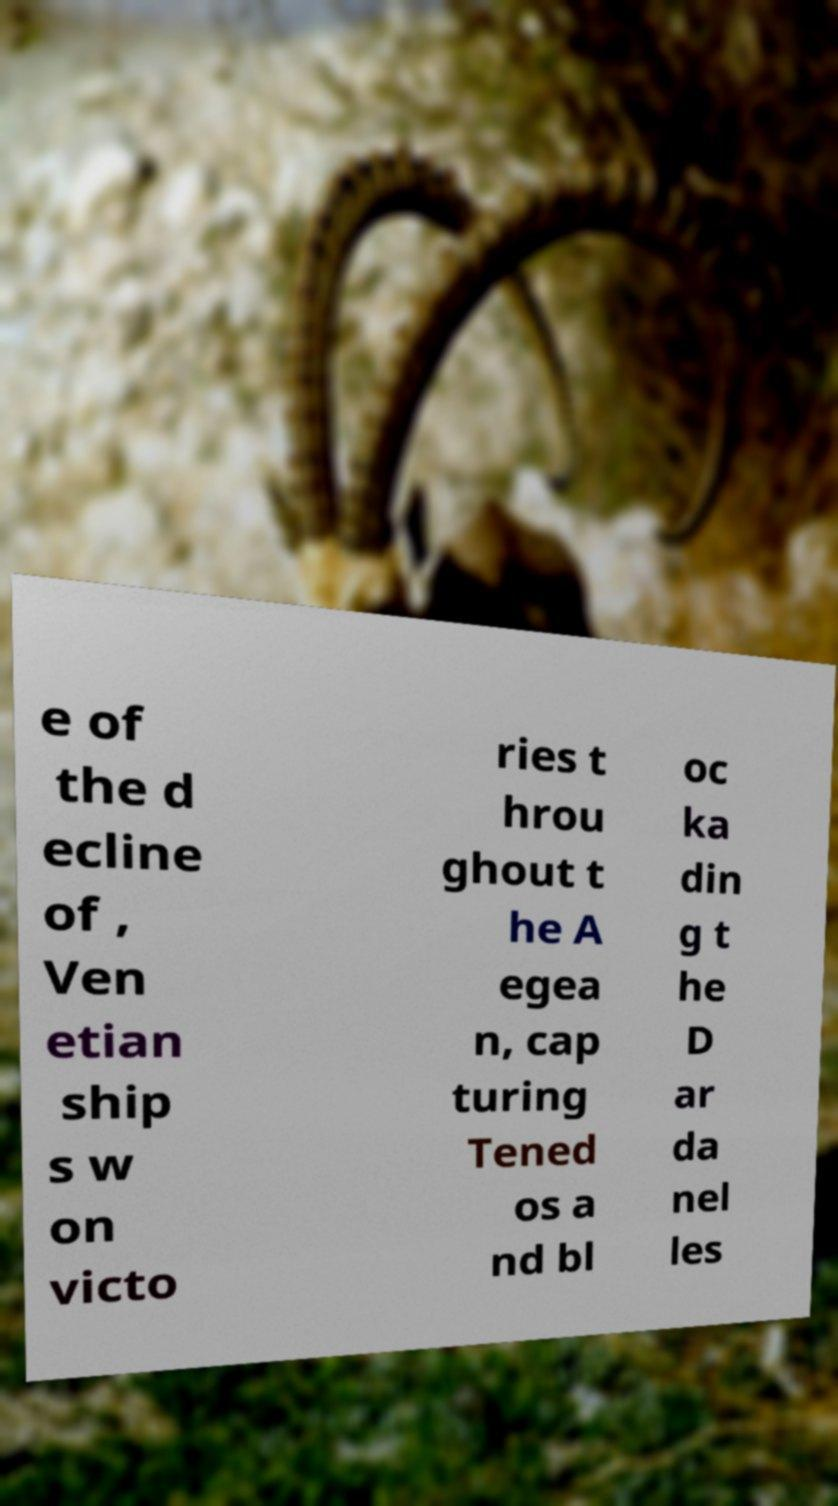Please read and relay the text visible in this image. What does it say? e of the d ecline of , Ven etian ship s w on victo ries t hrou ghout t he A egea n, cap turing Tened os a nd bl oc ka din g t he D ar da nel les 